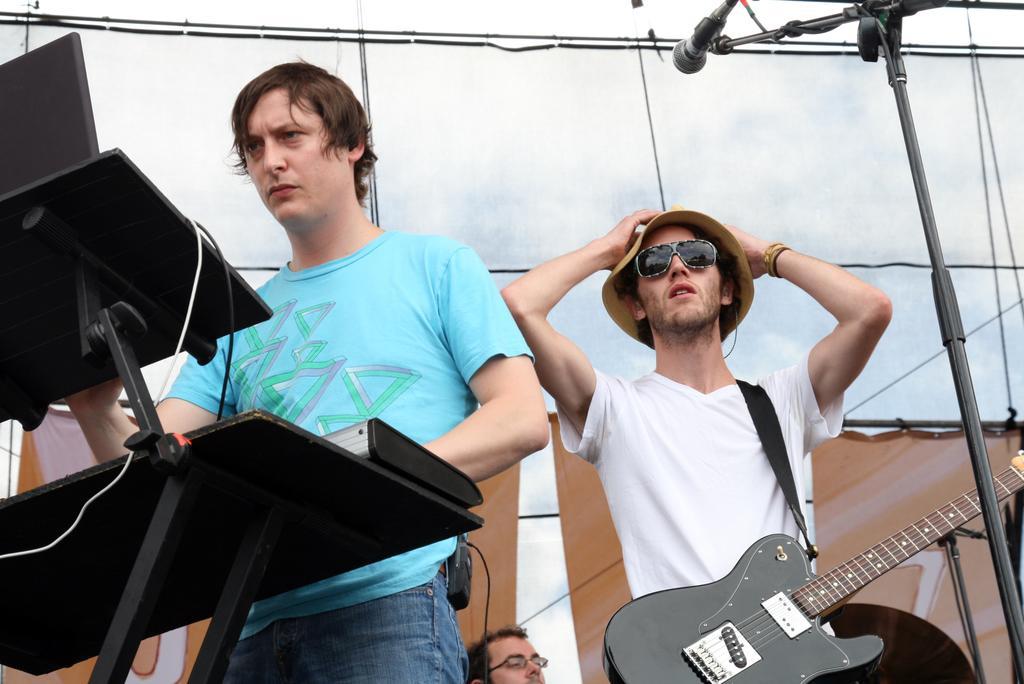Describe this image in one or two sentences. This image has three persons. One person at the left is wearing blue shirt and jeans keeping his hand on stand. At the right person with the white T-shirt, hanging guitar is wearing a hat and goggles. At the bottom of image there is a person wearing specs. At the right side there is a mike stand 